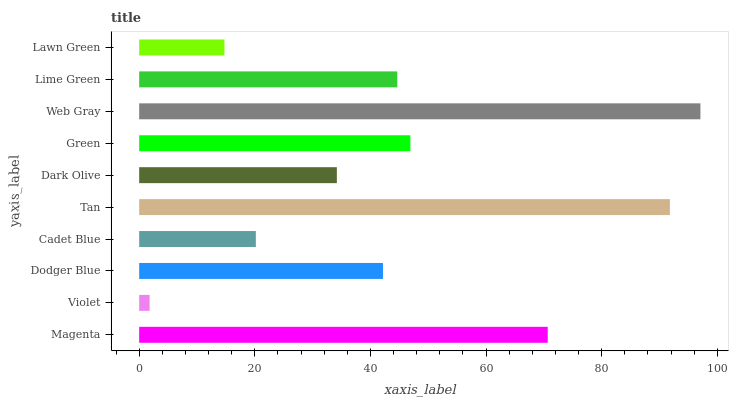Is Violet the minimum?
Answer yes or no. Yes. Is Web Gray the maximum?
Answer yes or no. Yes. Is Dodger Blue the minimum?
Answer yes or no. No. Is Dodger Blue the maximum?
Answer yes or no. No. Is Dodger Blue greater than Violet?
Answer yes or no. Yes. Is Violet less than Dodger Blue?
Answer yes or no. Yes. Is Violet greater than Dodger Blue?
Answer yes or no. No. Is Dodger Blue less than Violet?
Answer yes or no. No. Is Lime Green the high median?
Answer yes or no. Yes. Is Dodger Blue the low median?
Answer yes or no. Yes. Is Cadet Blue the high median?
Answer yes or no. No. Is Cadet Blue the low median?
Answer yes or no. No. 